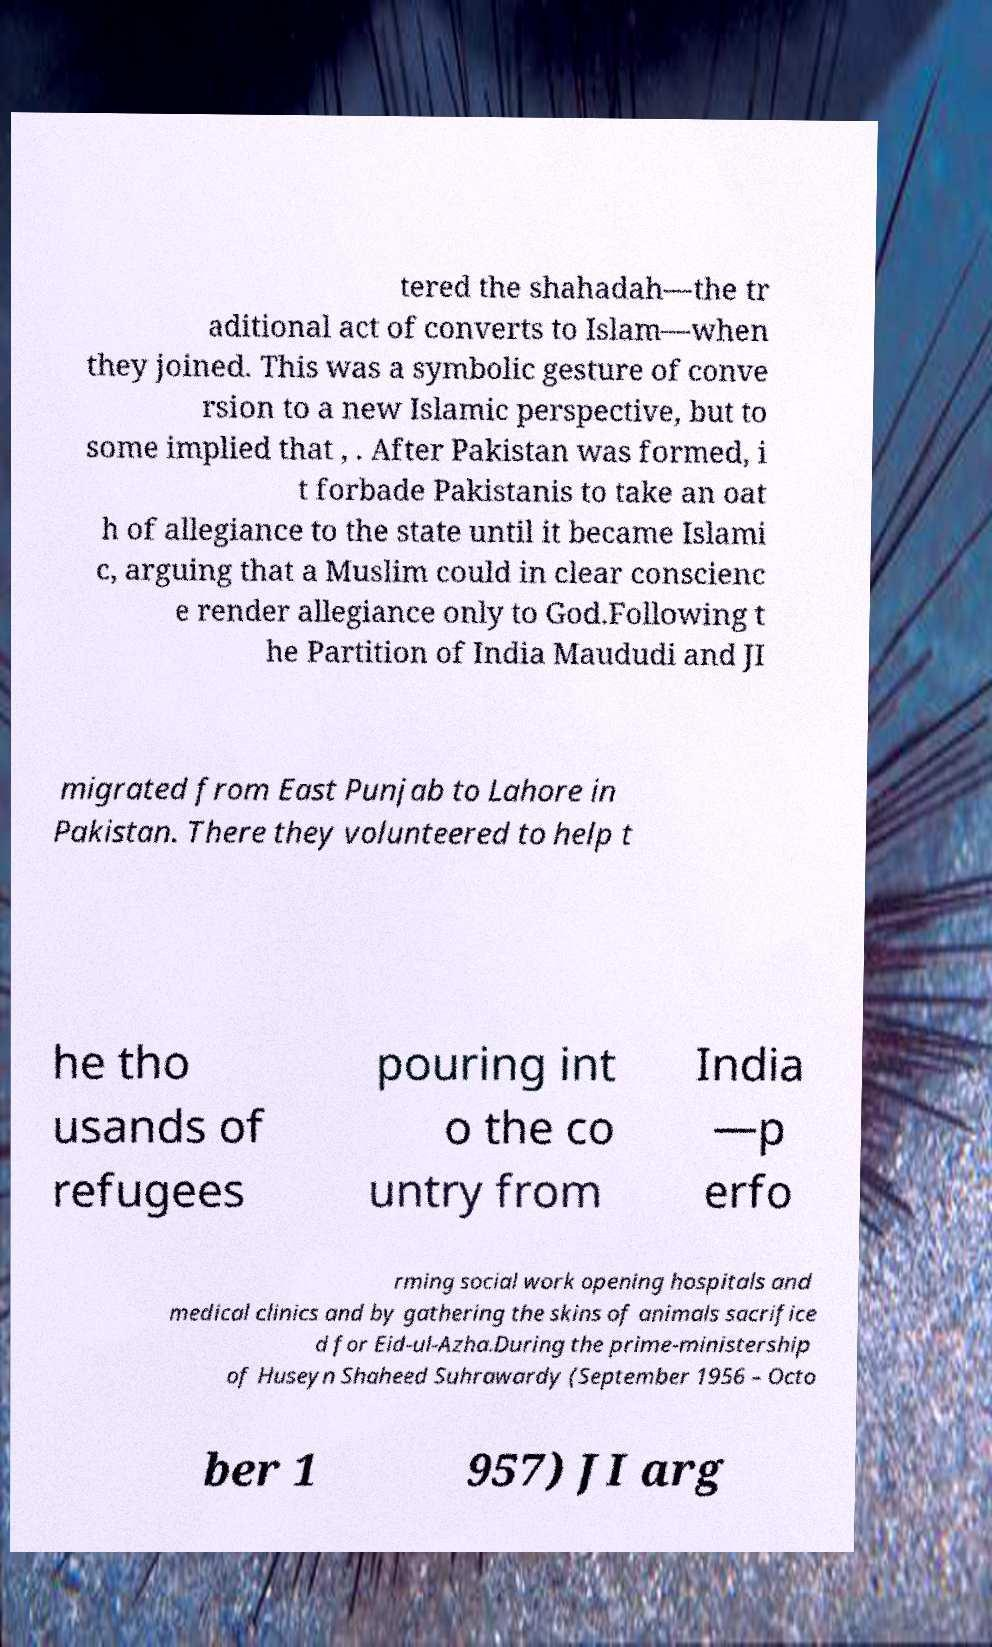Could you extract and type out the text from this image? tered the shahadah—the tr aditional act of converts to Islam—when they joined. This was a symbolic gesture of conve rsion to a new Islamic perspective, but to some implied that , . After Pakistan was formed, i t forbade Pakistanis to take an oat h of allegiance to the state until it became Islami c, arguing that a Muslim could in clear conscienc e render allegiance only to God.Following t he Partition of India Maududi and JI migrated from East Punjab to Lahore in Pakistan. There they volunteered to help t he tho usands of refugees pouring int o the co untry from India —p erfo rming social work opening hospitals and medical clinics and by gathering the skins of animals sacrifice d for Eid-ul-Azha.During the prime-ministership of Huseyn Shaheed Suhrawardy (September 1956 – Octo ber 1 957) JI arg 